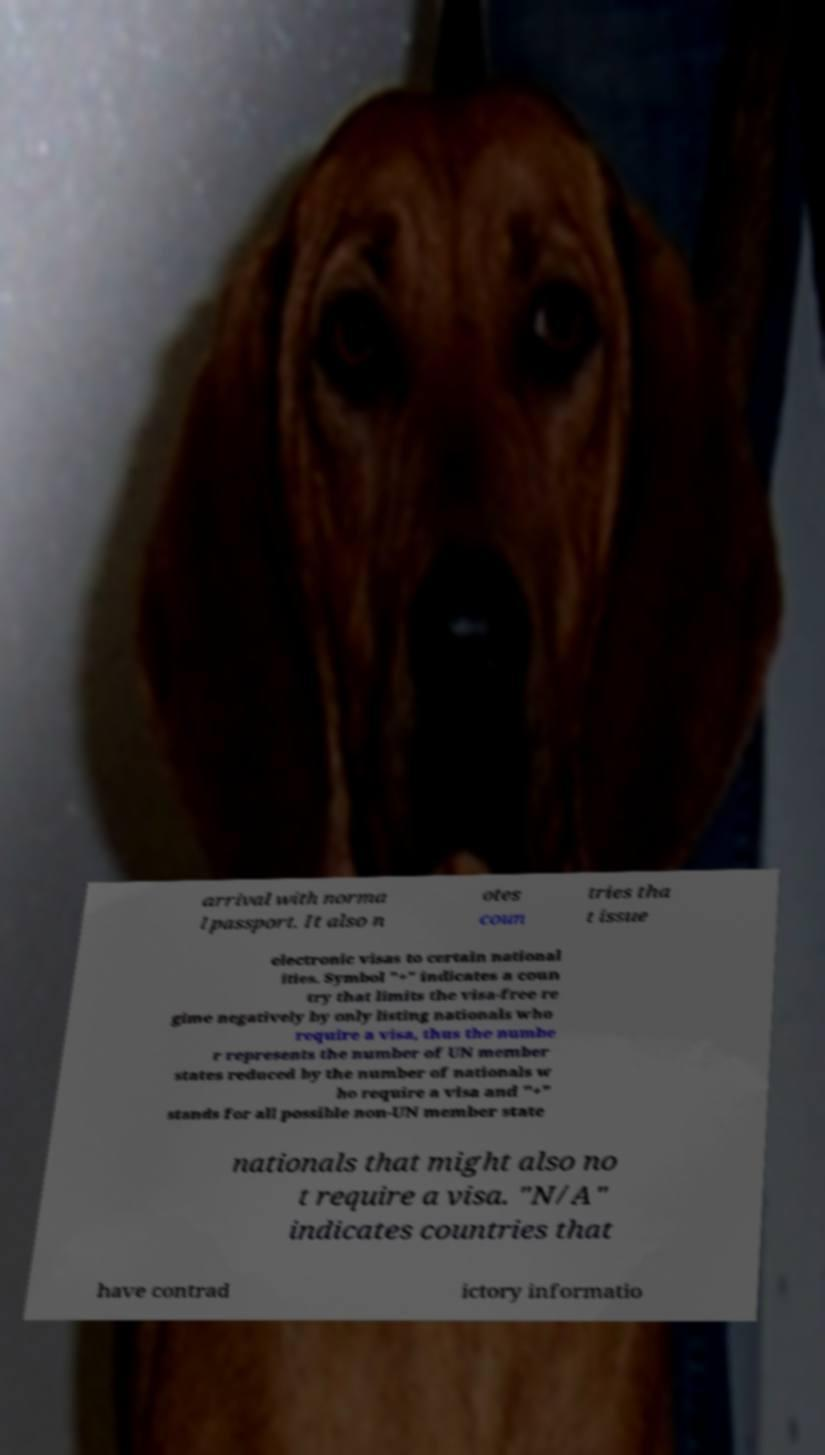What messages or text are displayed in this image? I need them in a readable, typed format. arrival with norma l passport. It also n otes coun tries tha t issue electronic visas to certain national ities. Symbol "+" indicates a coun try that limits the visa-free re gime negatively by only listing nationals who require a visa, thus the numbe r represents the number of UN member states reduced by the number of nationals w ho require a visa and "+" stands for all possible non-UN member state nationals that might also no t require a visa. "N/A" indicates countries that have contrad ictory informatio 